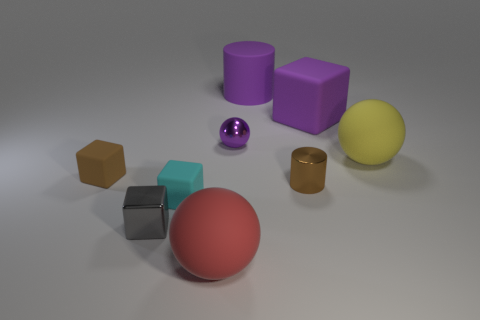What size is the ball that is made of the same material as the brown cylinder?
Provide a succinct answer. Small. What is the size of the object that is the same color as the metallic cylinder?
Keep it short and to the point. Small. Do the tiny shiny cylinder and the large cube have the same color?
Provide a succinct answer. No. There is a cube behind the big sphere that is behind the tiny cylinder; are there any big purple cubes that are in front of it?
Offer a terse response. No. How many objects are the same size as the gray metallic block?
Make the answer very short. 4. Is the size of the cylinder behind the yellow sphere the same as the matte ball on the left side of the shiny ball?
Offer a very short reply. Yes. What is the shape of the thing that is both to the left of the cyan object and to the right of the small brown rubber object?
Keep it short and to the point. Cube. Is there a big thing of the same color as the big cube?
Offer a very short reply. Yes. Is there a gray rubber cylinder?
Your answer should be compact. No. What color is the shiny object that is to the left of the small purple sphere?
Your response must be concise. Gray. 